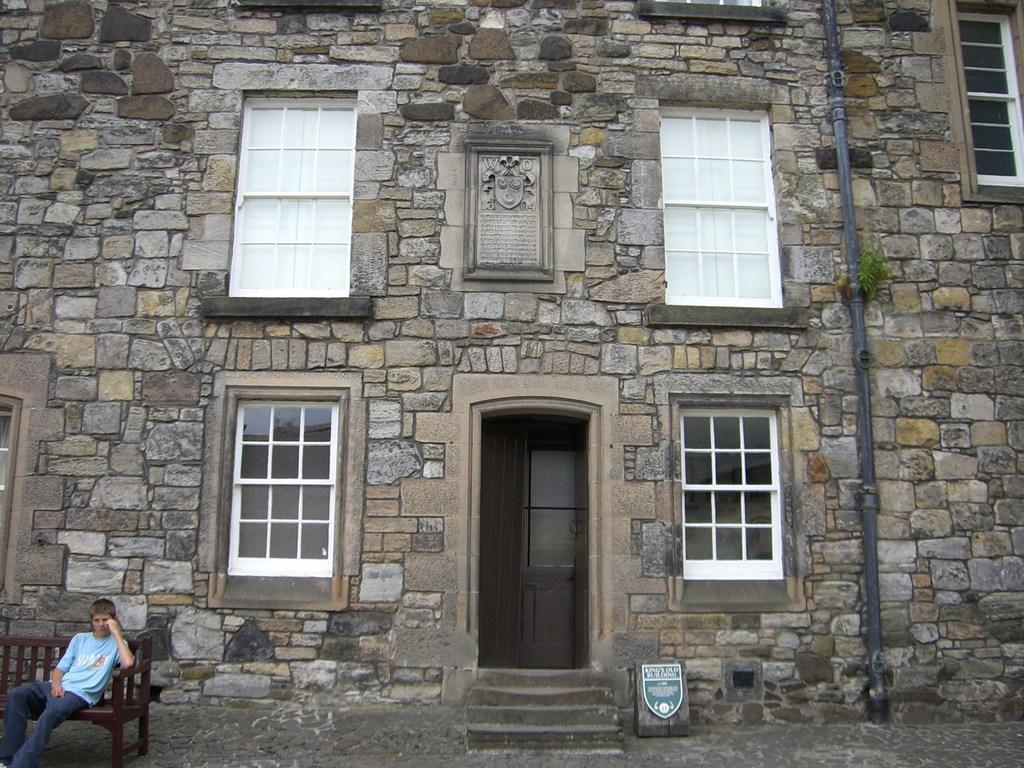What type of structure is visible in the image? There is a building in the image. What features can be seen on the building? The building has a door and windows. What is located on the right side of the image? There is a pipe on the right side of the image. Where is the person sitting in the image? The person is sitting on a bench on the left side of the image. What type of butter is being served on the bench next to the person? There is no butter present in the image; the person is sitting on a bench without any food or drink. 